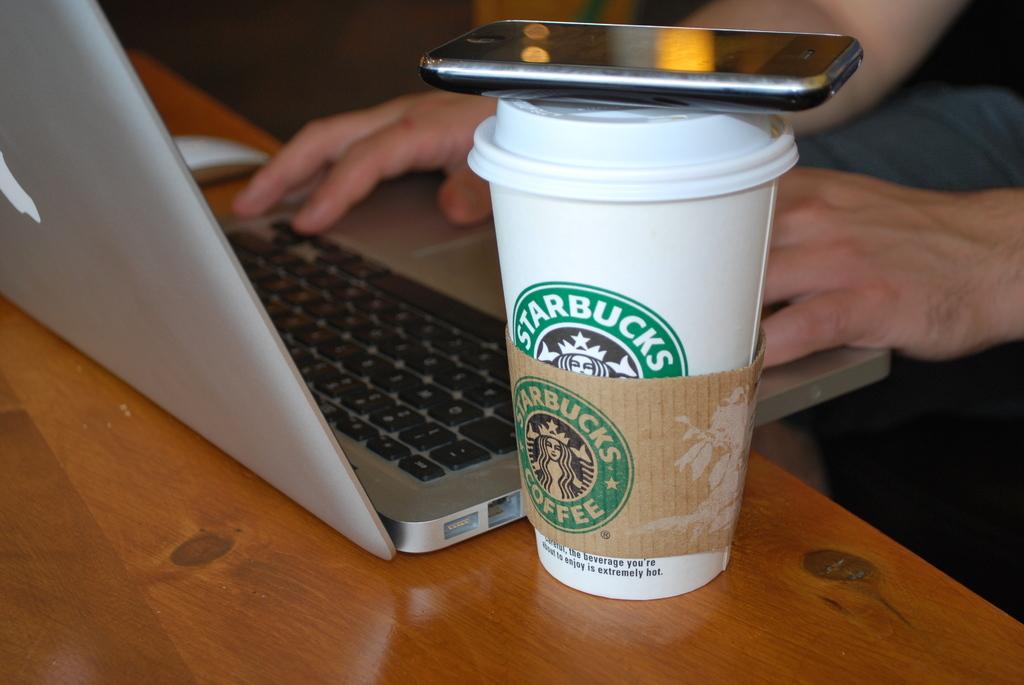What major coffee chain is this cup from?
Your response must be concise. Starbucks. Is there a warning on the cup?
Your answer should be very brief. Yes. 